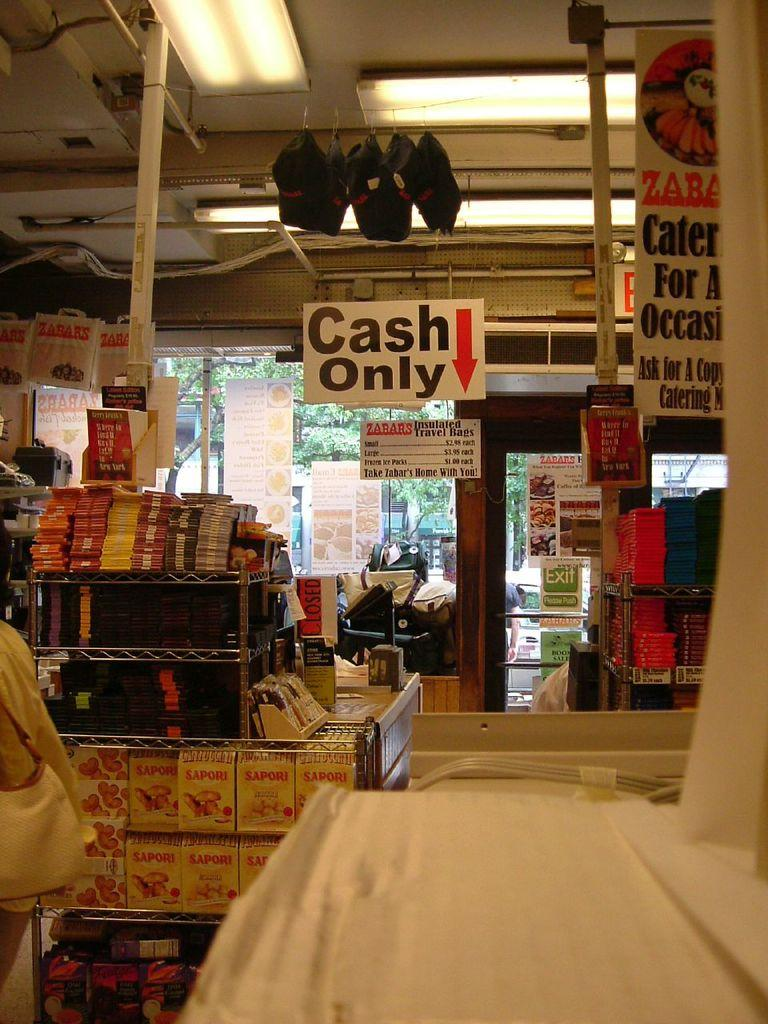<image>
Summarize the visual content of the image. Store front that has a sign which says "Cash only". 